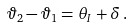Convert formula to latex. <formula><loc_0><loc_0><loc_500><loc_500>\vartheta _ { 2 } - \vartheta _ { 1 } = \theta _ { I } + \delta \, .</formula> 